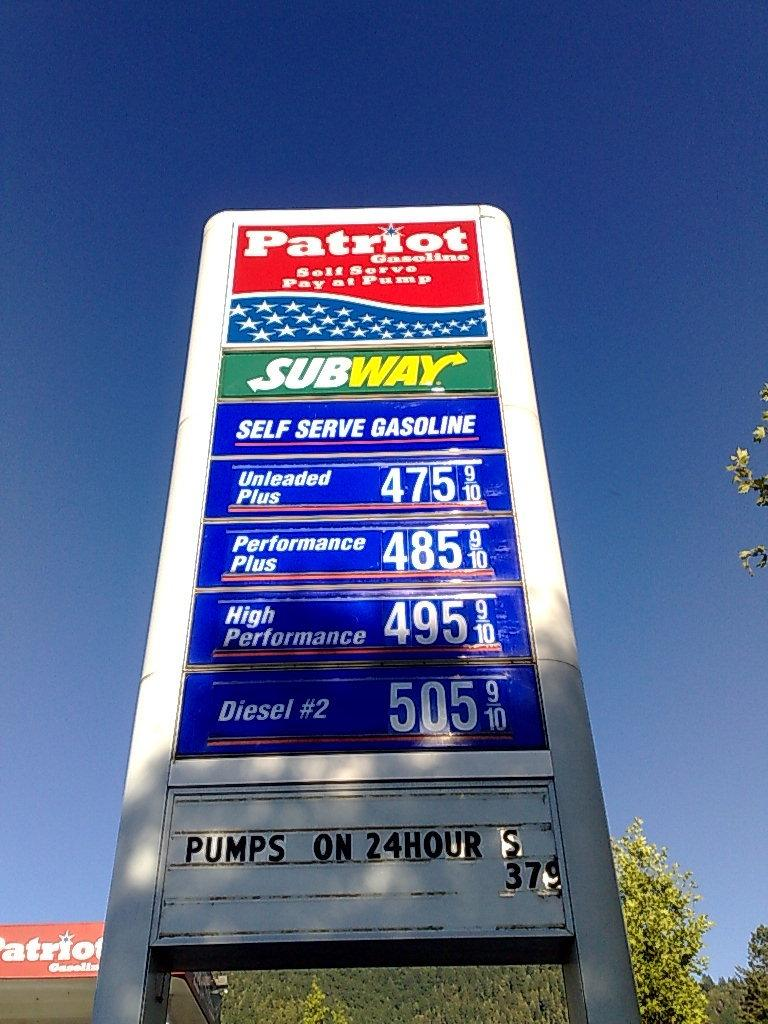<image>
Give a short and clear explanation of the subsequent image. Patriot Gas station with a Subway shop inside 